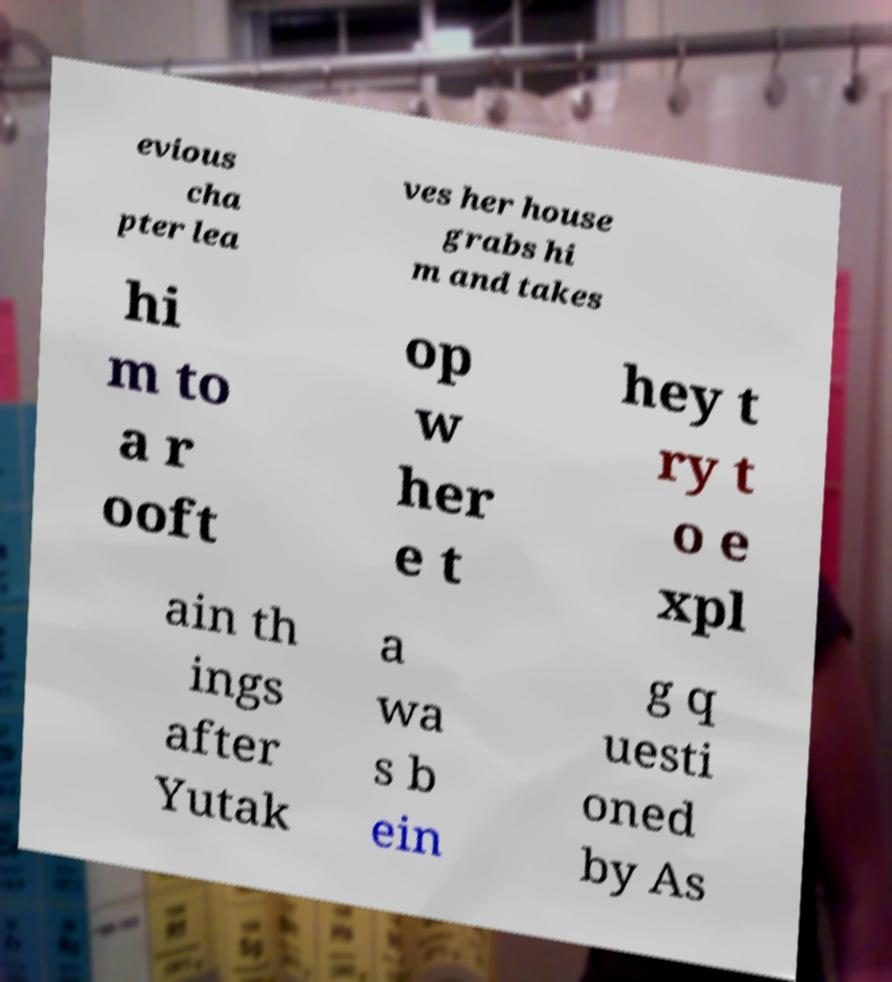Please read and relay the text visible in this image. What does it say? evious cha pter lea ves her house grabs hi m and takes hi m to a r ooft op w her e t hey t ry t o e xpl ain th ings after Yutak a wa s b ein g q uesti oned by As 